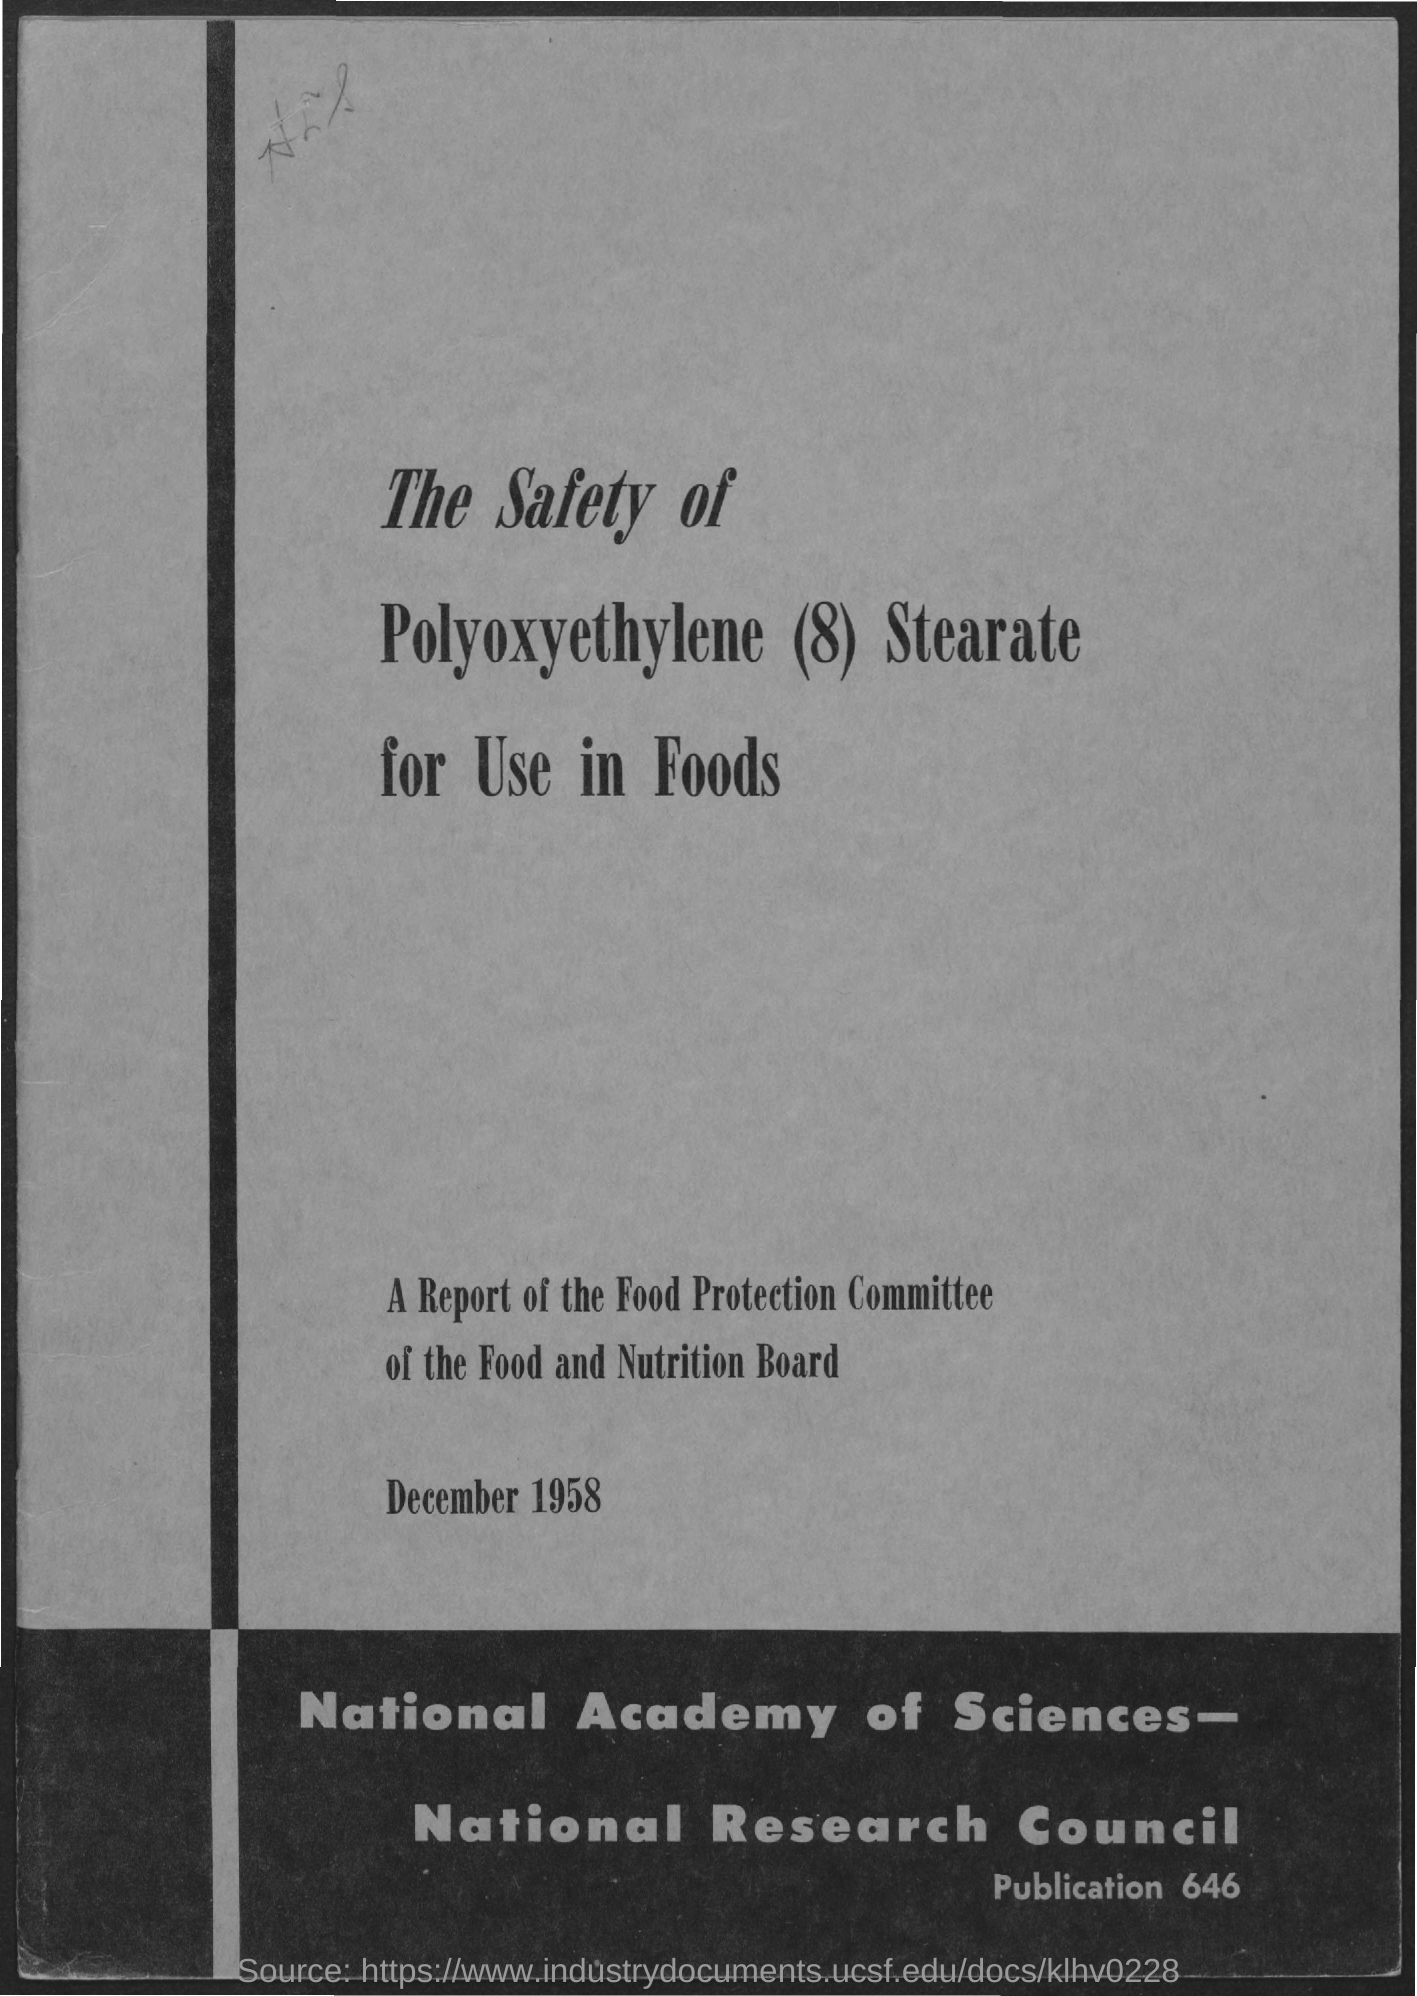What is number of publication?
Make the answer very short. 646. What is the title of page?
Ensure brevity in your answer.  The Safety of Polyoxyethylene (8) Stearate for Use in Foods. When is this report dated?
Your answer should be compact. December 1958. To whom does this report belongs to?
Your answer should be very brief. Food Protection Committee. 